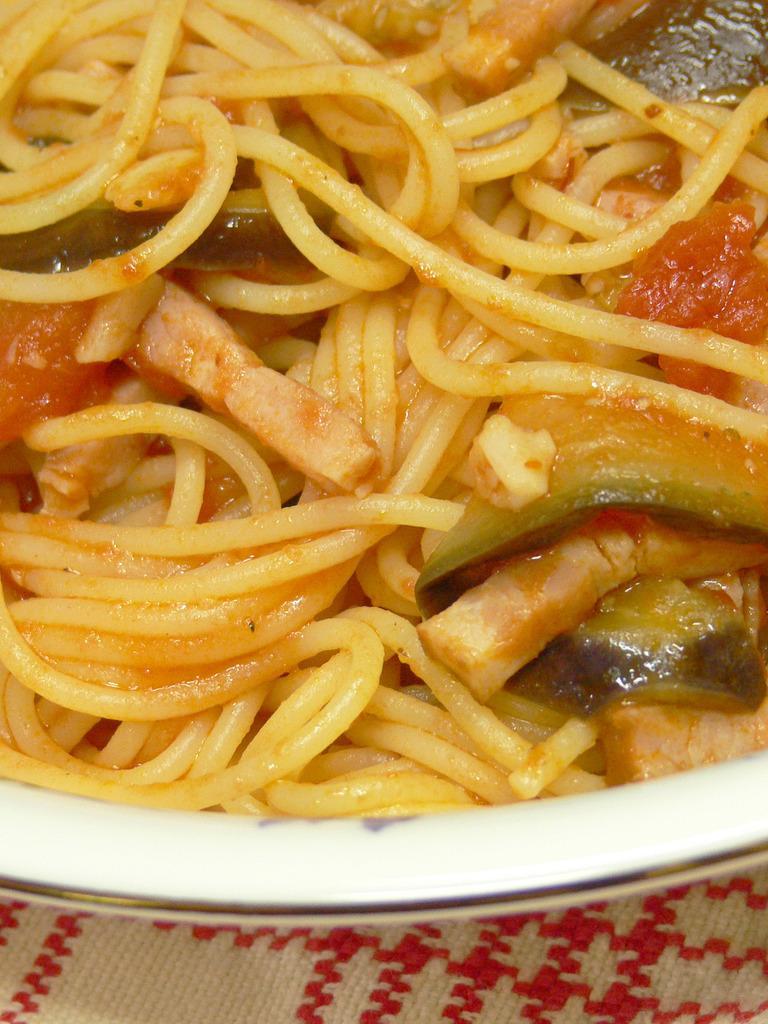Could you give a brief overview of what you see in this image? In this image there is food in the dish, the food is truncated towards the top of the image, there is a cloth truncated towards the bottom of the image. 